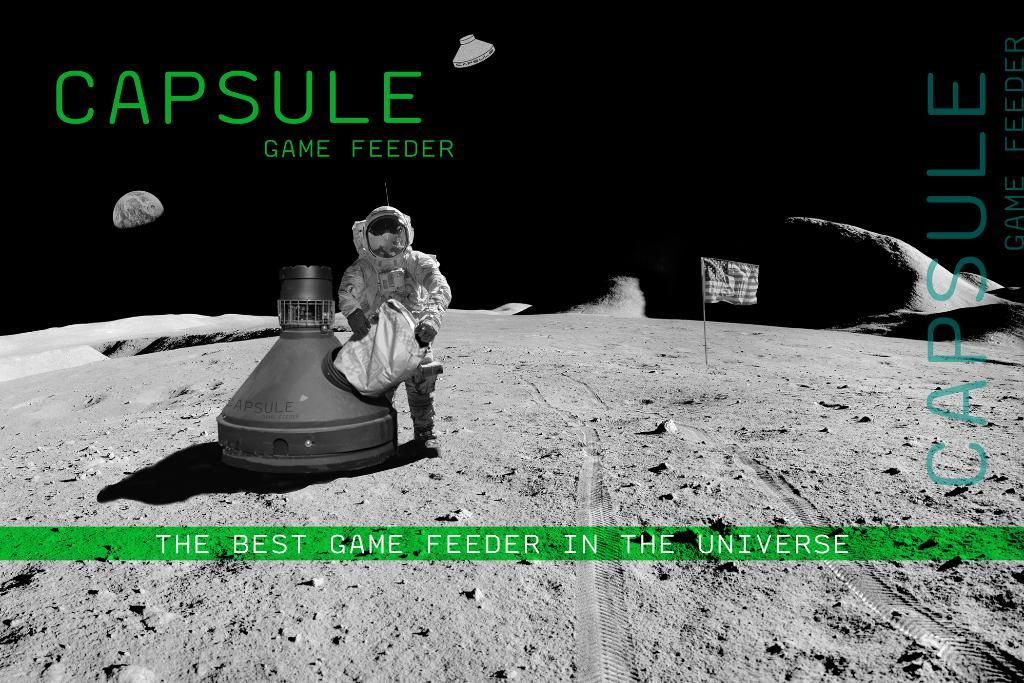What is the main subject in the middle of the image? There is a person in the middle of the image. What is located at the bottom of the image? There is a land at the bottom of the image, along with some text. Can you describe the text at the bottom of the image? Yes, there is a text at the bottom of the image. What can be seen in the background of the image? In the background of the image, there is a text, a flag, sand, and a moon. How many ducks are participating in the battle depicted in the image? There are no ducks or battle present in the image. What scientific theory is being discussed in the image? There is no scientific theory being discussed in the image. 